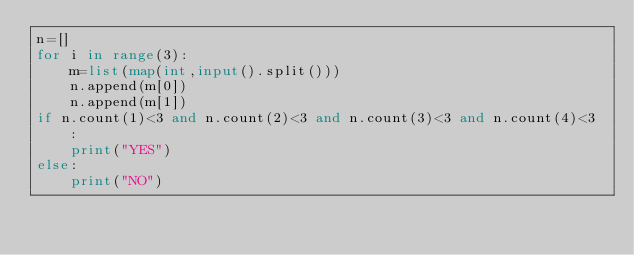<code> <loc_0><loc_0><loc_500><loc_500><_Python_>n=[]
for i in range(3):
    m=list(map(int,input().split()))
    n.append(m[0])
    n.append(m[1])
if n.count(1)<3 and n.count(2)<3 and n.count(3)<3 and n.count(4)<3 :
    print("YES")
else:
    print("NO")</code> 